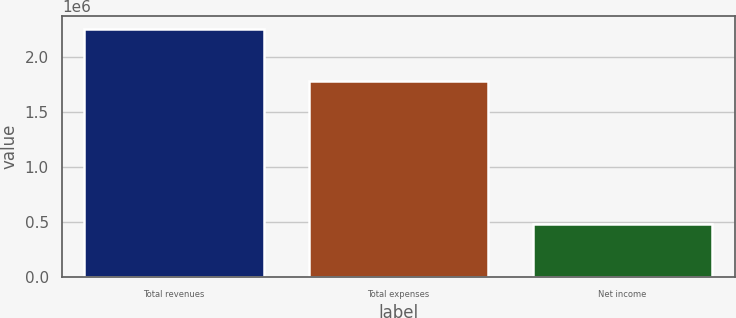Convert chart. <chart><loc_0><loc_0><loc_500><loc_500><bar_chart><fcel>Total revenues<fcel>Total expenses<fcel>Net income<nl><fcel>2.25535e+06<fcel>1.77916e+06<fcel>476192<nl></chart> 